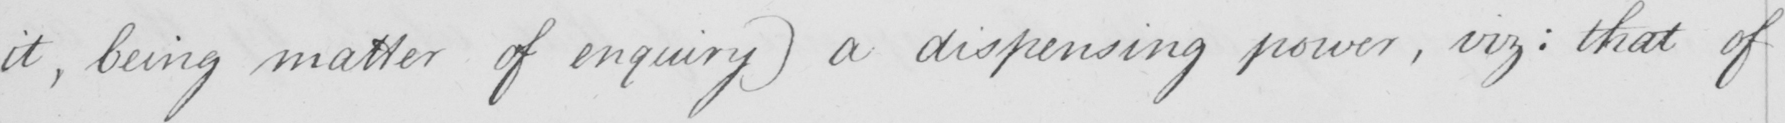What text is written in this handwritten line? it , being matter of enquiry )  a dispensing power , viz :  that of 